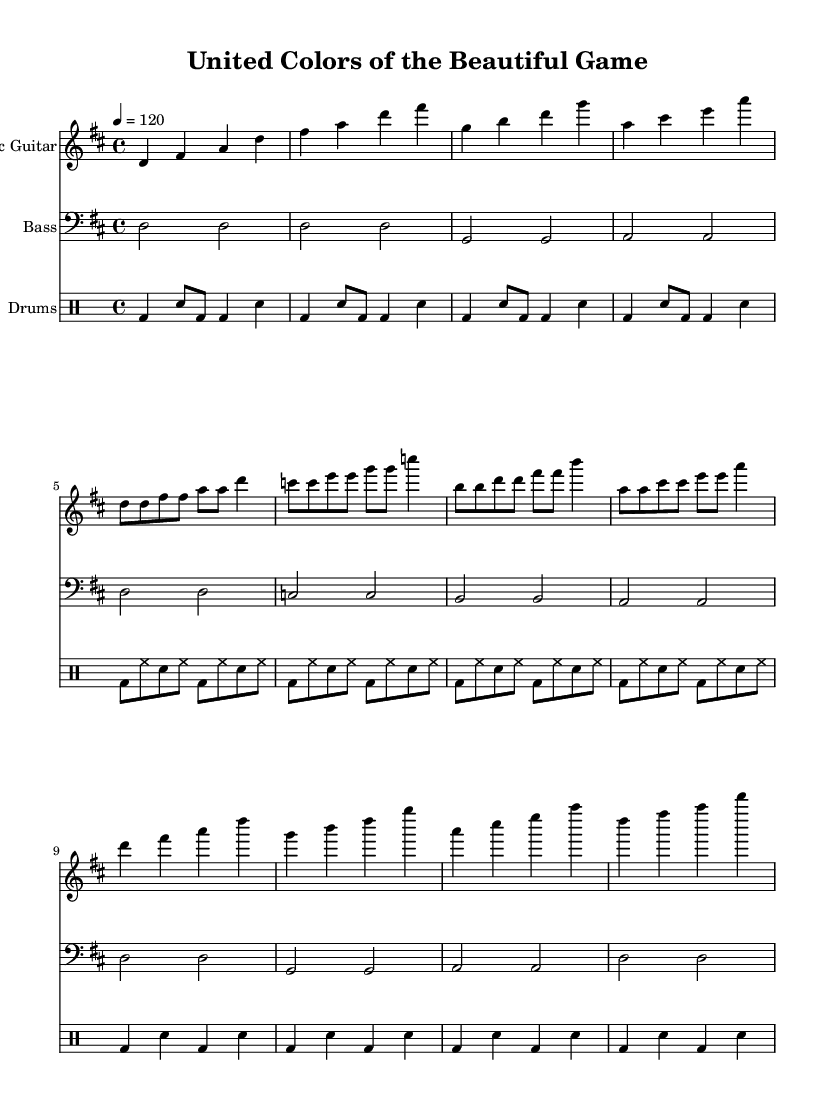What is the key signature of this music? The key signature indicated at the beginning of the sheet music shows two sharps (F# and C#), which is characteristic of D major.
Answer: D major What is the time signature of this music? The time signature is found in the notation right after the key signature and is marked with a 4 over 4, which indicates the music is in common time.
Answer: 4/4 What is the tempo marking for this piece? The tempo marking is located below the global settings and indicates that the music should be played at 120 beats per minute, which is moderately fast.
Answer: 120 How many bars are in the chorus section? To determine the number of bars in the chorus, we need to visually count them in the written music. There are four distinct bars, showing a clear structure in this part of the song.
Answer: 4 What instrument is primarily featured in the introduction? The introduction of the piece is notably marked for the electric guitar, which plays the opening riffs before other instruments are introduced.
Answer: Electric Guitar How do the drum patterns in the verse differ from the chorus? Analyzing the sheet music, the verse features a more intricate pattern with alternating kick and snare hits, while the chorus simplifies the rhythm to focus on strong beats.
Answer: Complex What musical elements reflect the theme of unity in this piece? The repetition of certain melodies and the strong rhythmic foundation in the music suggests an element of unity, as all instruments work together to create a cohesive sound.
Answer: Repetition 